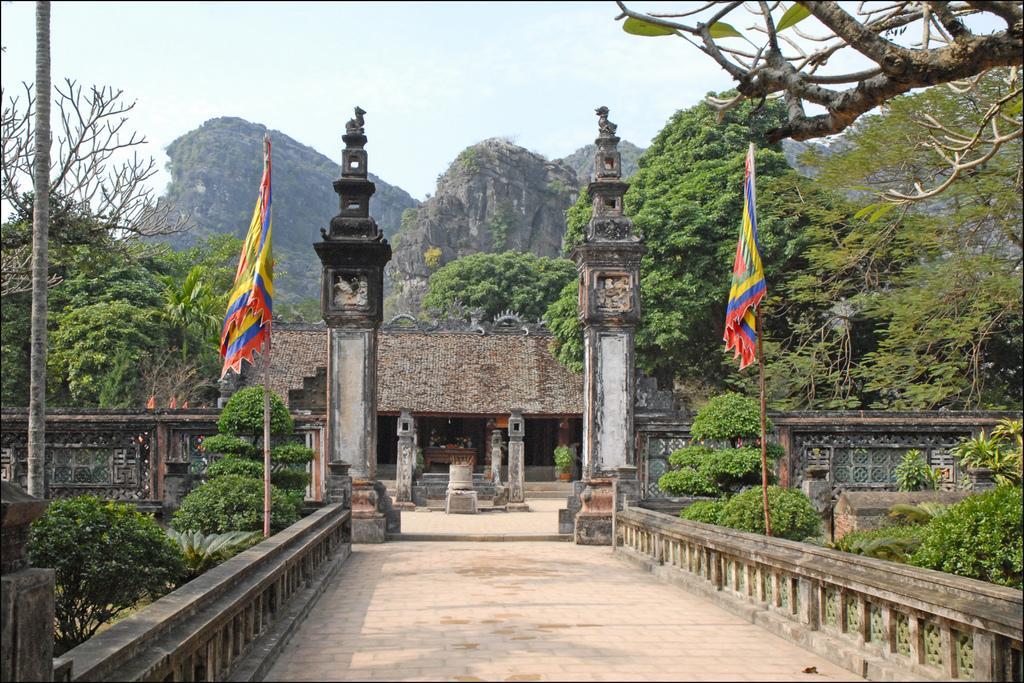Please provide a concise description of this image. In the image there is path in the middle with plants on either side with fence, there are flags behind the fence, in the front there is an ancient home with mountains and tree behind it all over the place and above its sky. 